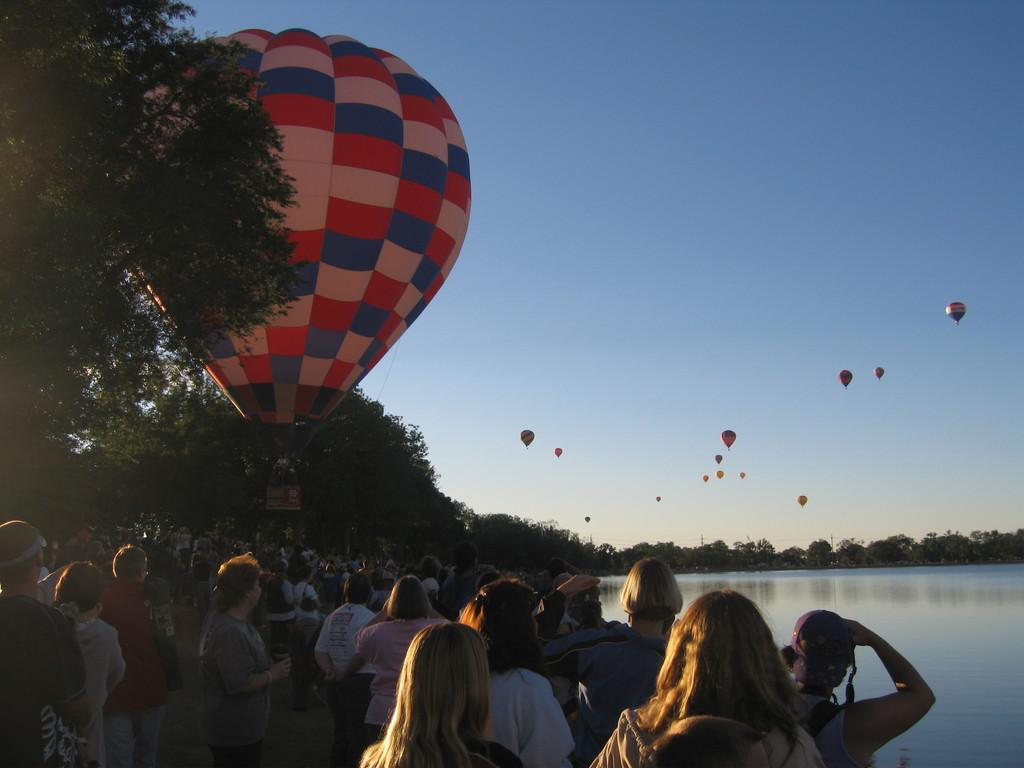What is happening in the image? There are people standing in the image. What can be seen on the right side of the image? There is water on the right side of the image. What is visible in the background of the image? There are trees visible in the background of the image. What is present in the sky in the image? There are air balloons in the sky. What type of yarn is being used by the people in the image? There is no yarn present in the image; the people are standing and there are air balloons in the sky. 